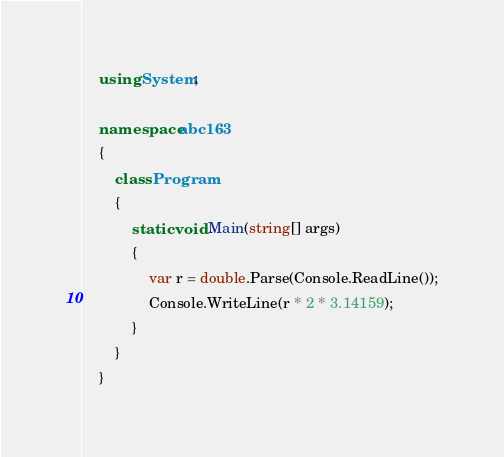Convert code to text. <code><loc_0><loc_0><loc_500><loc_500><_C#_>    using System;
     
    namespace abc163
    {
        class Program
        {
            static void Main(string[] args)
            {
                var r = double.Parse(Console.ReadLine());
                Console.WriteLine(r * 2 * 3.14159);
            }
        }
    }</code> 